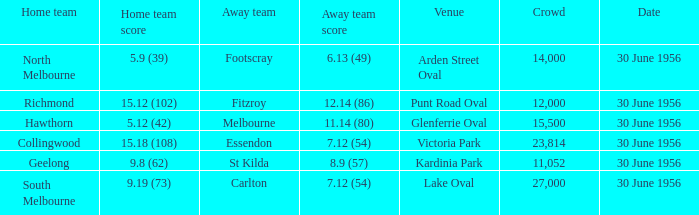What is the home team at Victoria Park with an Away team score of 7.12 (54) and more than 12,000 people? Collingwood. 